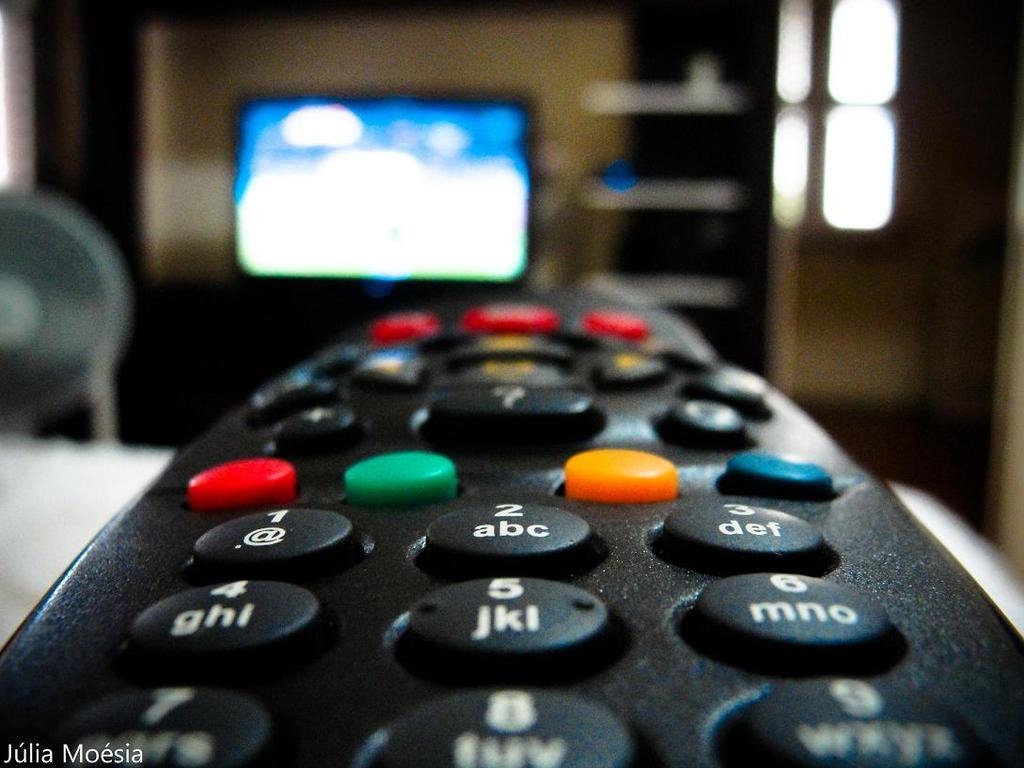What is the biggest number on the tv remote?
Offer a very short reply. 9. 